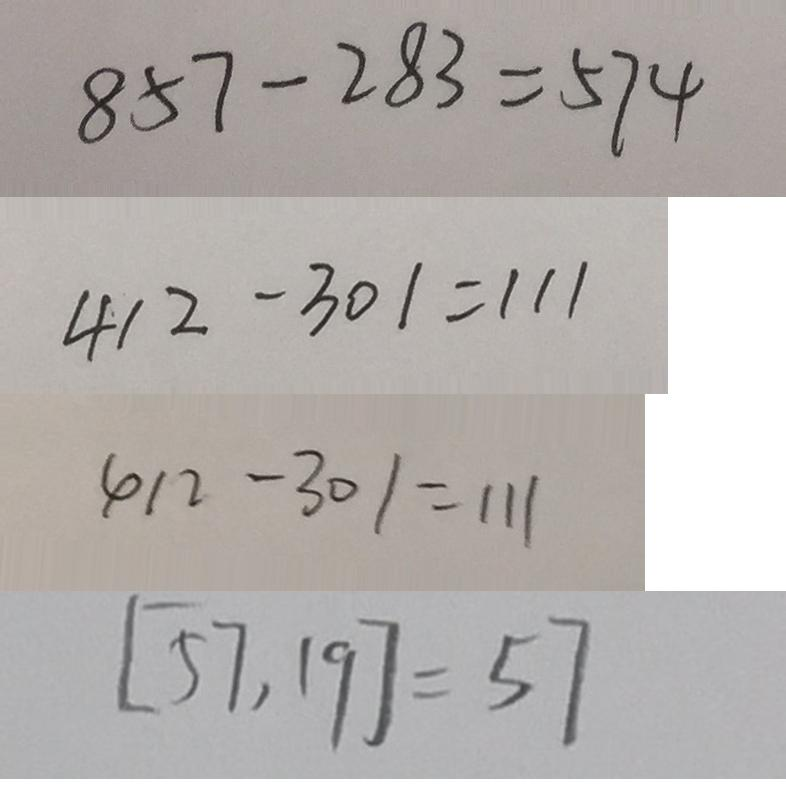<formula> <loc_0><loc_0><loc_500><loc_500>8 5 7 - 2 8 3 = 5 7 4 
 4 1 2 - 3 0 1 = 1 1 1 
 4 1 2 - 3 0 1 = 1 1 1 
 [ 5 7 , 1 9 ] = 5 7</formula> 